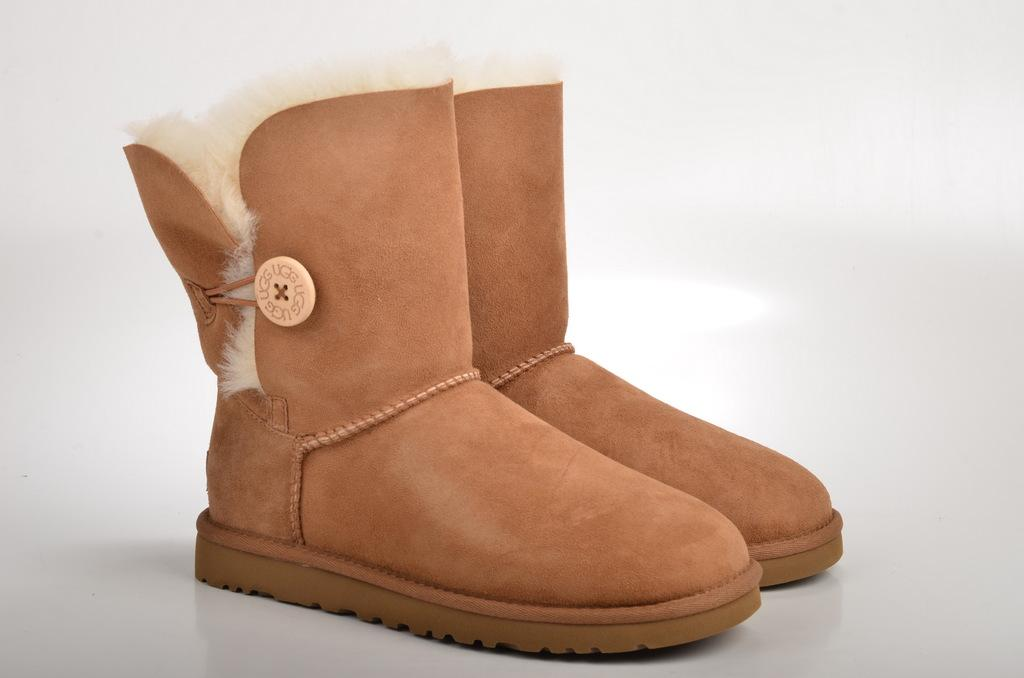What type of footwear is present in the image? There are boots in the image. What color are the boots? The boots are brown in color. What type of silver comb is being used to style the boots in the image? There is no silver comb or any styling activity involving the boots in the image. 